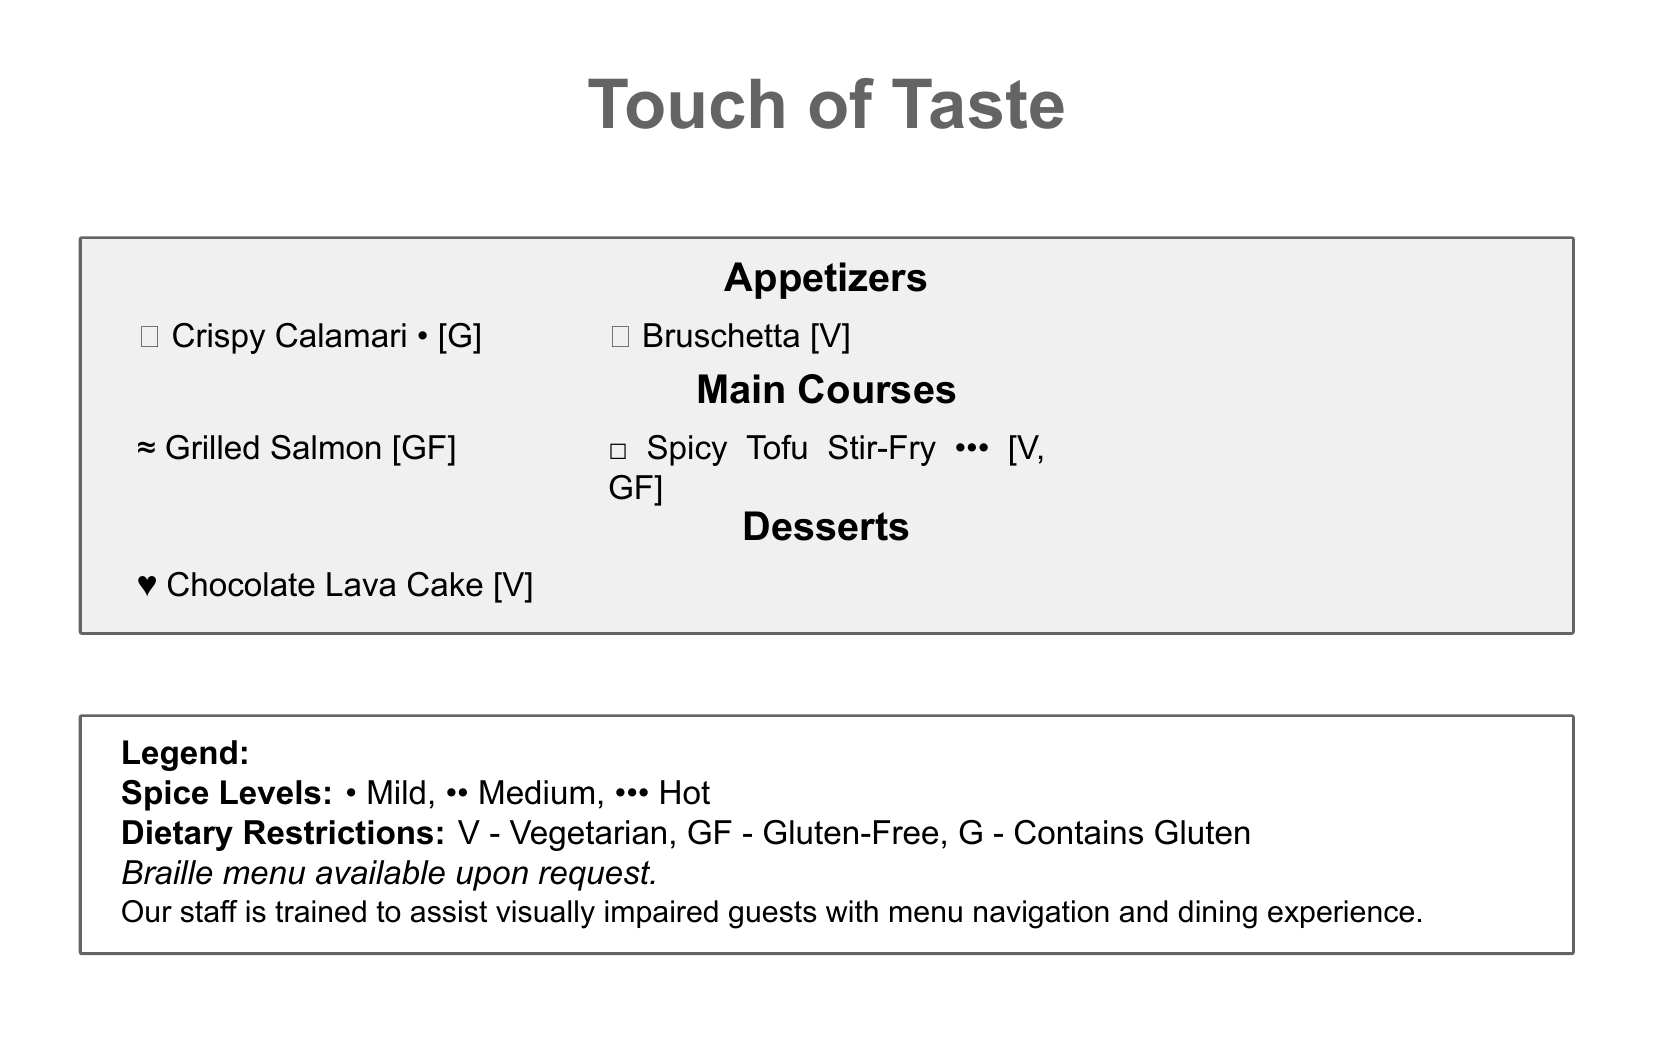What is the name of the restaurant? The restaurant is called "Touch of Taste," which is prominently displayed at the top of the menu.
Answer: Touch of Taste What type of dish is the Spicy Tofu Stir-Fry? It is categorized under Main Courses, indicating that it is a main dish.
Answer: Main Course How many spice levels are defined in the legend? The legend includes three spice levels; mild, medium, and hot.
Answer: Three What is the symbol for vegetarian dishes? The document indicates that "V" represents vegetarian dishes.
Answer: V Which appetizer is listed as gluten-free? The Crispy Calamari is indicated with the symbol "[G]," meaning it is gluten-free.
Answer: Crispy Calamari What is the spice level of the Grilled Salmon? The Grilled Salmon dish is marked with a symbol indicating it has no spice level, making it plain.
Answer: No spice What dessert is available for vegetarians? The menu lists the Chocolate Lava Cake, which is marked as vegetarian.
Answer: Chocolate Lava Cake What does the symbol ••• represent in the spice levels? The symbol ••• indicates that the dish is hot, according to the legend provided.
Answer: Hot How can visually impaired guests receive assistance? The menu states that staff is trained to assist visually impaired guests with navigation and dining experience.
Answer: Staff assistance 